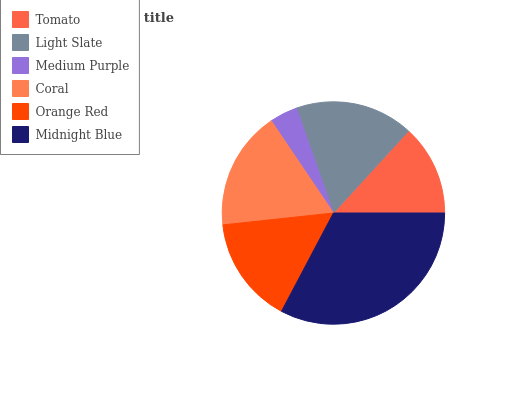Is Medium Purple the minimum?
Answer yes or no. Yes. Is Midnight Blue the maximum?
Answer yes or no. Yes. Is Light Slate the minimum?
Answer yes or no. No. Is Light Slate the maximum?
Answer yes or no. No. Is Light Slate greater than Tomato?
Answer yes or no. Yes. Is Tomato less than Light Slate?
Answer yes or no. Yes. Is Tomato greater than Light Slate?
Answer yes or no. No. Is Light Slate less than Tomato?
Answer yes or no. No. Is Light Slate the high median?
Answer yes or no. Yes. Is Orange Red the low median?
Answer yes or no. Yes. Is Coral the high median?
Answer yes or no. No. Is Coral the low median?
Answer yes or no. No. 